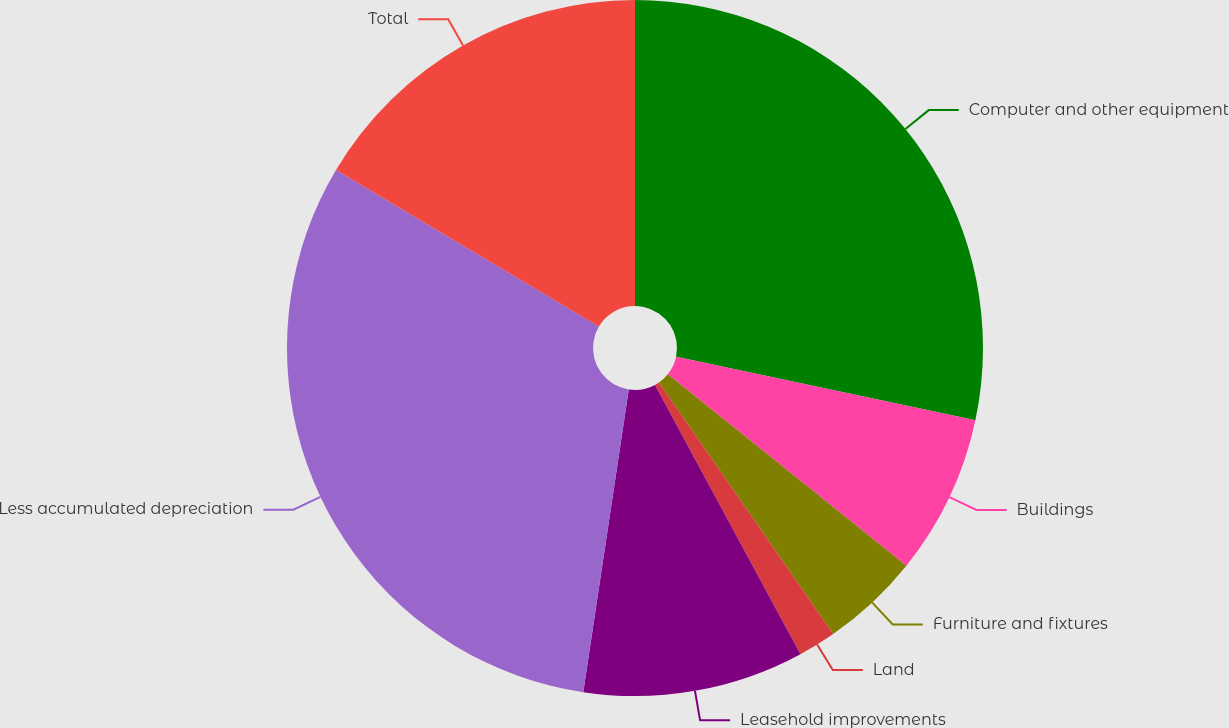Convert chart to OTSL. <chart><loc_0><loc_0><loc_500><loc_500><pie_chart><fcel>Computer and other equipment<fcel>Buildings<fcel>Furniture and fixtures<fcel>Land<fcel>Leasehold improvements<fcel>Less accumulated depreciation<fcel>Total<nl><fcel>28.33%<fcel>7.43%<fcel>4.59%<fcel>1.76%<fcel>10.26%<fcel>31.17%<fcel>16.45%<nl></chart> 